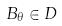<formula> <loc_0><loc_0><loc_500><loc_500>B _ { \theta } \in D</formula> 